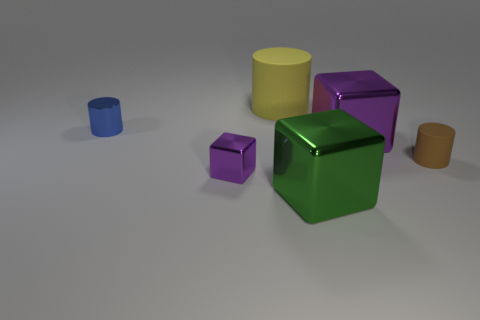Subtract all yellow cylinders. Subtract all green balls. How many cylinders are left? 2 Add 3 green shiny objects. How many objects exist? 9 Subtract 1 green cubes. How many objects are left? 5 Subtract all small purple shiny objects. Subtract all tiny blue shiny cylinders. How many objects are left? 4 Add 4 small blue metal things. How many small blue metal things are left? 5 Add 3 small shiny cylinders. How many small shiny cylinders exist? 4 